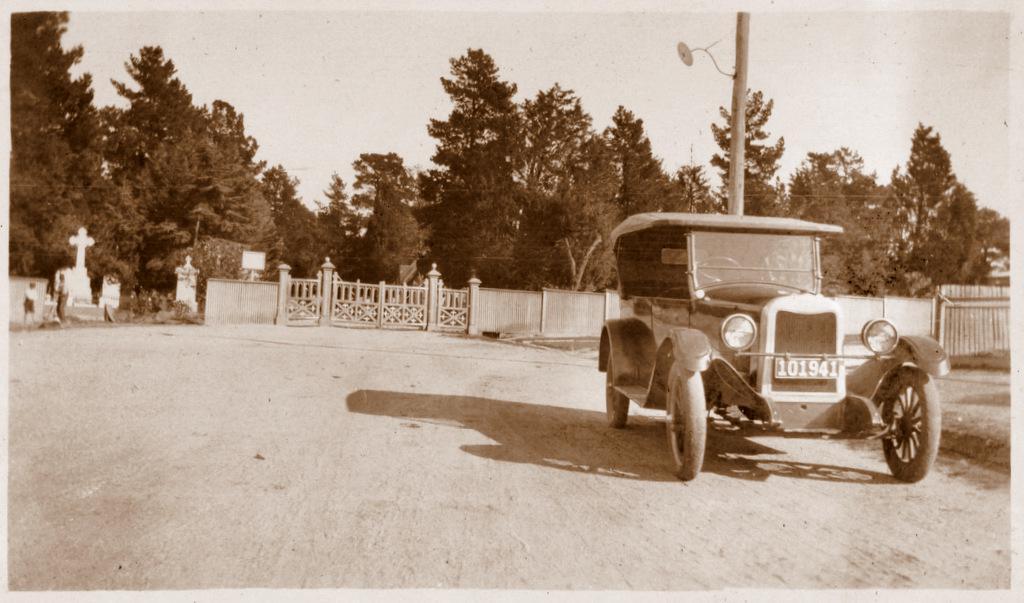In one or two sentences, can you explain what this image depicts? In this picture there is a jeep on the right side of the image and there is a boundary, trees, and headstones in the background area of the image. 